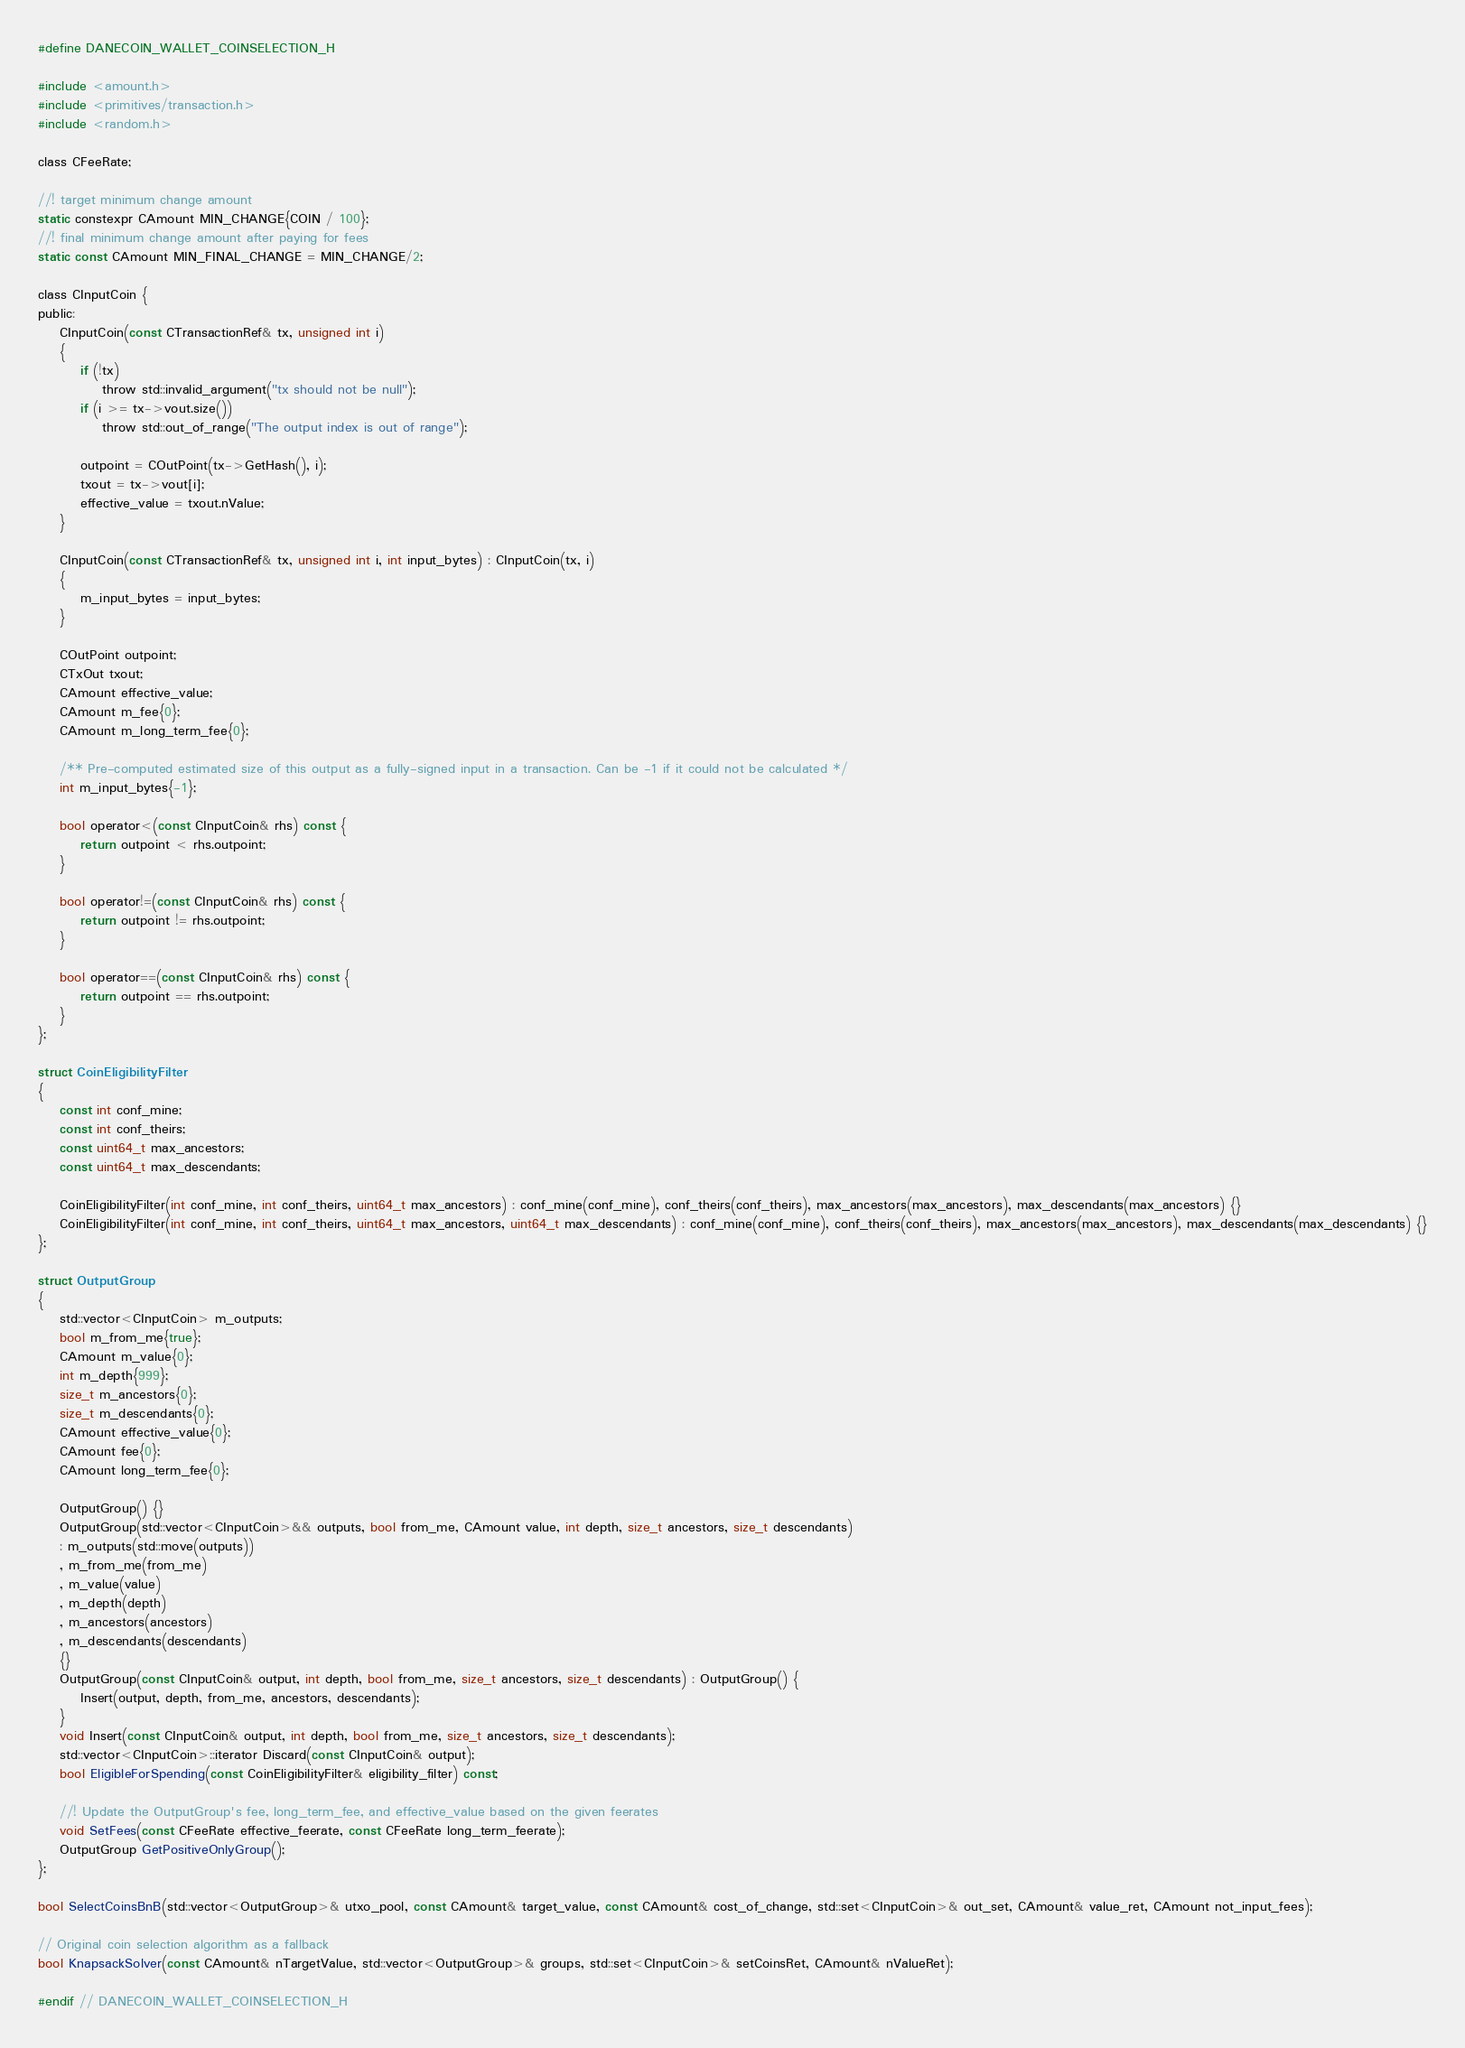<code> <loc_0><loc_0><loc_500><loc_500><_C_>#define DANECOIN_WALLET_COINSELECTION_H

#include <amount.h>
#include <primitives/transaction.h>
#include <random.h>

class CFeeRate;

//! target minimum change amount
static constexpr CAmount MIN_CHANGE{COIN / 100};
//! final minimum change amount after paying for fees
static const CAmount MIN_FINAL_CHANGE = MIN_CHANGE/2;

class CInputCoin {
public:
    CInputCoin(const CTransactionRef& tx, unsigned int i)
    {
        if (!tx)
            throw std::invalid_argument("tx should not be null");
        if (i >= tx->vout.size())
            throw std::out_of_range("The output index is out of range");

        outpoint = COutPoint(tx->GetHash(), i);
        txout = tx->vout[i];
        effective_value = txout.nValue;
    }

    CInputCoin(const CTransactionRef& tx, unsigned int i, int input_bytes) : CInputCoin(tx, i)
    {
        m_input_bytes = input_bytes;
    }

    COutPoint outpoint;
    CTxOut txout;
    CAmount effective_value;
    CAmount m_fee{0};
    CAmount m_long_term_fee{0};

    /** Pre-computed estimated size of this output as a fully-signed input in a transaction. Can be -1 if it could not be calculated */
    int m_input_bytes{-1};

    bool operator<(const CInputCoin& rhs) const {
        return outpoint < rhs.outpoint;
    }

    bool operator!=(const CInputCoin& rhs) const {
        return outpoint != rhs.outpoint;
    }

    bool operator==(const CInputCoin& rhs) const {
        return outpoint == rhs.outpoint;
    }
};

struct CoinEligibilityFilter
{
    const int conf_mine;
    const int conf_theirs;
    const uint64_t max_ancestors;
    const uint64_t max_descendants;

    CoinEligibilityFilter(int conf_mine, int conf_theirs, uint64_t max_ancestors) : conf_mine(conf_mine), conf_theirs(conf_theirs), max_ancestors(max_ancestors), max_descendants(max_ancestors) {}
    CoinEligibilityFilter(int conf_mine, int conf_theirs, uint64_t max_ancestors, uint64_t max_descendants) : conf_mine(conf_mine), conf_theirs(conf_theirs), max_ancestors(max_ancestors), max_descendants(max_descendants) {}
};

struct OutputGroup
{
    std::vector<CInputCoin> m_outputs;
    bool m_from_me{true};
    CAmount m_value{0};
    int m_depth{999};
    size_t m_ancestors{0};
    size_t m_descendants{0};
    CAmount effective_value{0};
    CAmount fee{0};
    CAmount long_term_fee{0};

    OutputGroup() {}
    OutputGroup(std::vector<CInputCoin>&& outputs, bool from_me, CAmount value, int depth, size_t ancestors, size_t descendants)
    : m_outputs(std::move(outputs))
    , m_from_me(from_me)
    , m_value(value)
    , m_depth(depth)
    , m_ancestors(ancestors)
    , m_descendants(descendants)
    {}
    OutputGroup(const CInputCoin& output, int depth, bool from_me, size_t ancestors, size_t descendants) : OutputGroup() {
        Insert(output, depth, from_me, ancestors, descendants);
    }
    void Insert(const CInputCoin& output, int depth, bool from_me, size_t ancestors, size_t descendants);
    std::vector<CInputCoin>::iterator Discard(const CInputCoin& output);
    bool EligibleForSpending(const CoinEligibilityFilter& eligibility_filter) const;

    //! Update the OutputGroup's fee, long_term_fee, and effective_value based on the given feerates
    void SetFees(const CFeeRate effective_feerate, const CFeeRate long_term_feerate);
    OutputGroup GetPositiveOnlyGroup();
};

bool SelectCoinsBnB(std::vector<OutputGroup>& utxo_pool, const CAmount& target_value, const CAmount& cost_of_change, std::set<CInputCoin>& out_set, CAmount& value_ret, CAmount not_input_fees);

// Original coin selection algorithm as a fallback
bool KnapsackSolver(const CAmount& nTargetValue, std::vector<OutputGroup>& groups, std::set<CInputCoin>& setCoinsRet, CAmount& nValueRet);

#endif // DANECOIN_WALLET_COINSELECTION_H
</code> 